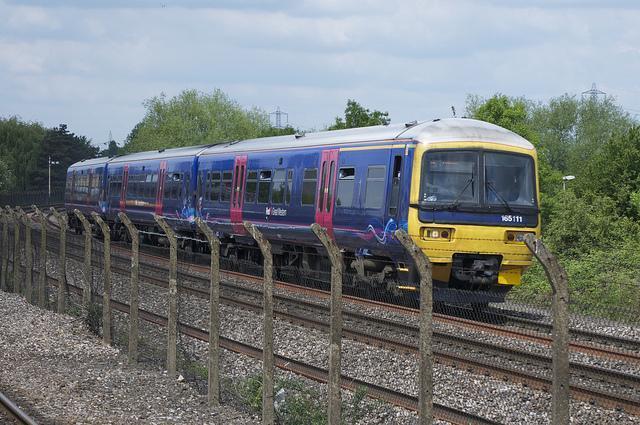How many people have visible tattoos in the image?
Give a very brief answer. 0. 